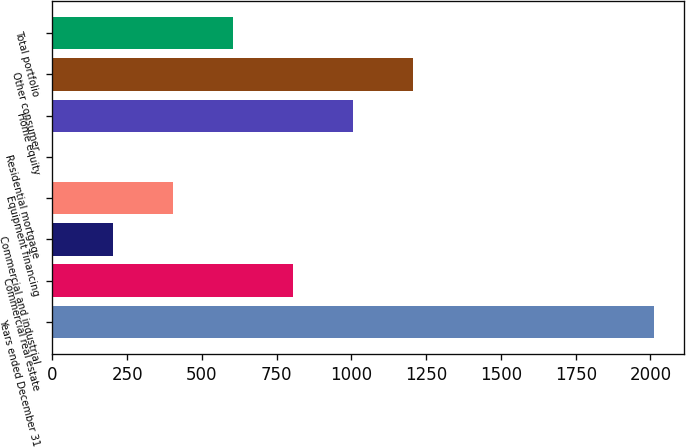Convert chart to OTSL. <chart><loc_0><loc_0><loc_500><loc_500><bar_chart><fcel>Years ended December 31<fcel>Commercial real estate<fcel>Commercial and industrial<fcel>Equipment financing<fcel>Residential mortgage<fcel>Home equity<fcel>Other consumer<fcel>Total portfolio<nl><fcel>2012<fcel>804.89<fcel>201.35<fcel>402.53<fcel>0.17<fcel>1006.07<fcel>1207.25<fcel>603.71<nl></chart> 